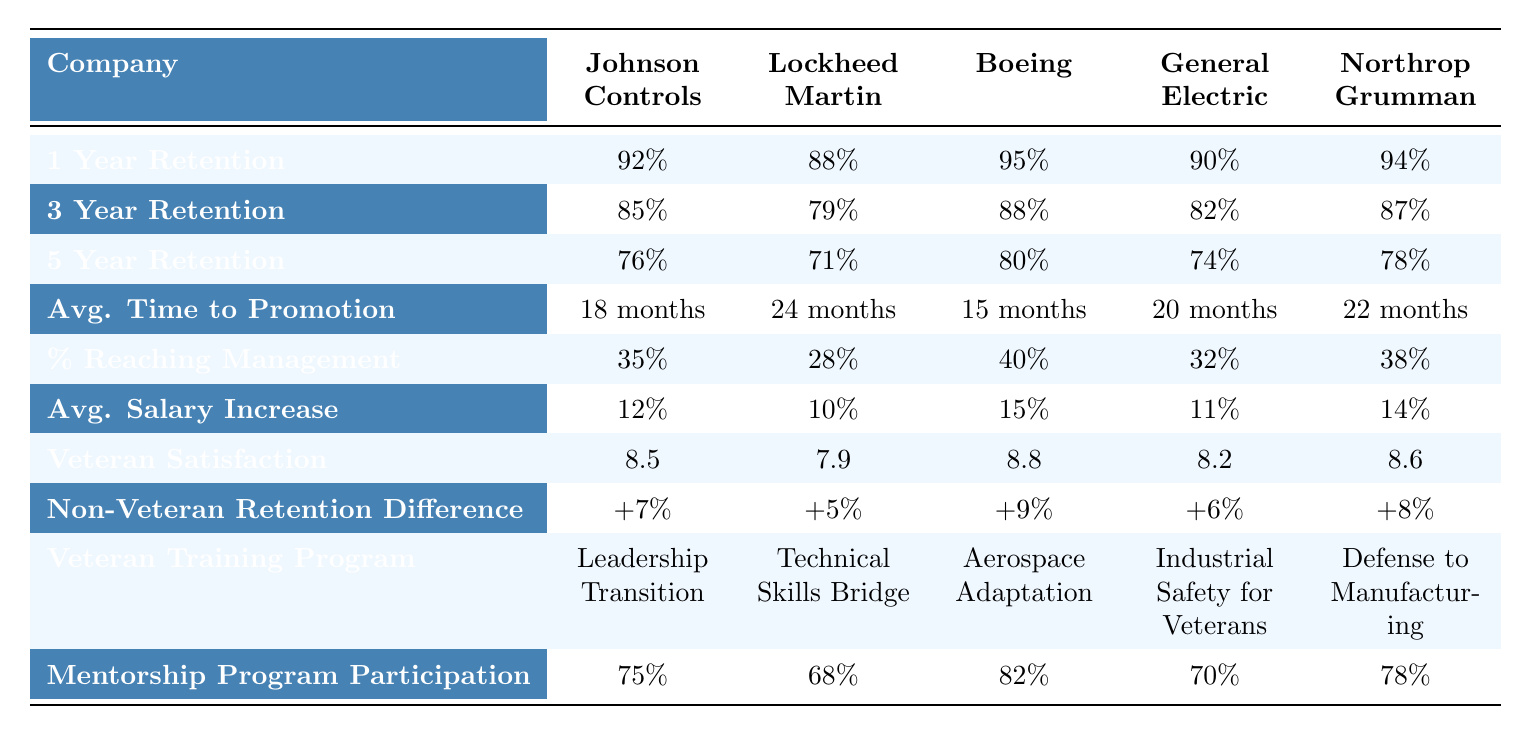What is the highest 5-year retention rate among the companies listed? To find the highest 5-year retention rate, we need to look at the 5 Year Retention row. The values are 76%, 71%, 80%, 74%, and 78%. The highest value is 80% from Boeing.
Answer: 80% Which company has the highest average salary increase percentage? By checking the Avg. Salary Increase row, we see the values are 12%, 10%, 15%, 11%, and 14%. The highest value is 15%, which belongs to Boeing.
Answer: 15% How many companies have a veteran satisfaction score of 8.5 or higher? Looking at the Veteran Satisfaction row, the scores are 8.5, 7.9, 8.8, 8.2, and 8.6. The scores that are 8.5 or higher are 8.5, 8.8, 8.6, and 8.2. Therefore, 4 companies meet this criterion.
Answer: 4 Which manufacturing position has the shortest average time to promotion? The Avg. Time to Promotion values are 18 months, 24 months, 15 months, 20 months, and 22 months. The shortest time is 15 months, corresponding to the Process Engineer position.
Answer: 15 months Is there a significant difference in retention rates between veterans and non-veterans across the companies? Yes, all values under Non-Veteran Retention Difference row are positive, indicating that veterans have a higher retention rate. The smallest difference is +5% for Lockheed Martin, and the largest is +9% for Boeing.
Answer: Yes What is the average retention rate after 3 years across all companies? To calculate the average retention rate, sum the values from the 3 Year Retention row: (85 + 79 + 88 + 82 + 87) = 421. Then divide this by the number of companies, which is 5. So, 421 / 5 = 84.2%.
Answer: 84.2% Which company has the lowest percentage of veterans reaching management? Looking at the % Reaching Management row, the values are 35%, 28%, 40%, 32%, and 38%. The lowest percentage is 28%, attributed to Lockheed Martin.
Answer: 28% If we consider the retention rates at 1 year, what is the difference between the highest and lowest? The 1 Year Retention values are 92%, 88%, 95%, 90%, and 94%. The highest rate is 95% (Boeing) and the lowest is 88% (Lockheed Martin). The difference is 95% - 88% = 7%.
Answer: 7% What unique training programs are offered to veterans at Northrop Grumman? The row for Veteran Training Program lists "Defense to Manufacturing" specifically for Northrop Grumman.
Answer: Defense to Manufacturing How does the mentorship program participation rate compare among the companies? Checking the Mentorship Program Participation row gives us rates of 75%, 68%, 82%, 70%, and 78%. The highest rate (82%) is from Boeing, while the lowest (68%) is from Lockheed Martin.
Answer: 68% to 82% 